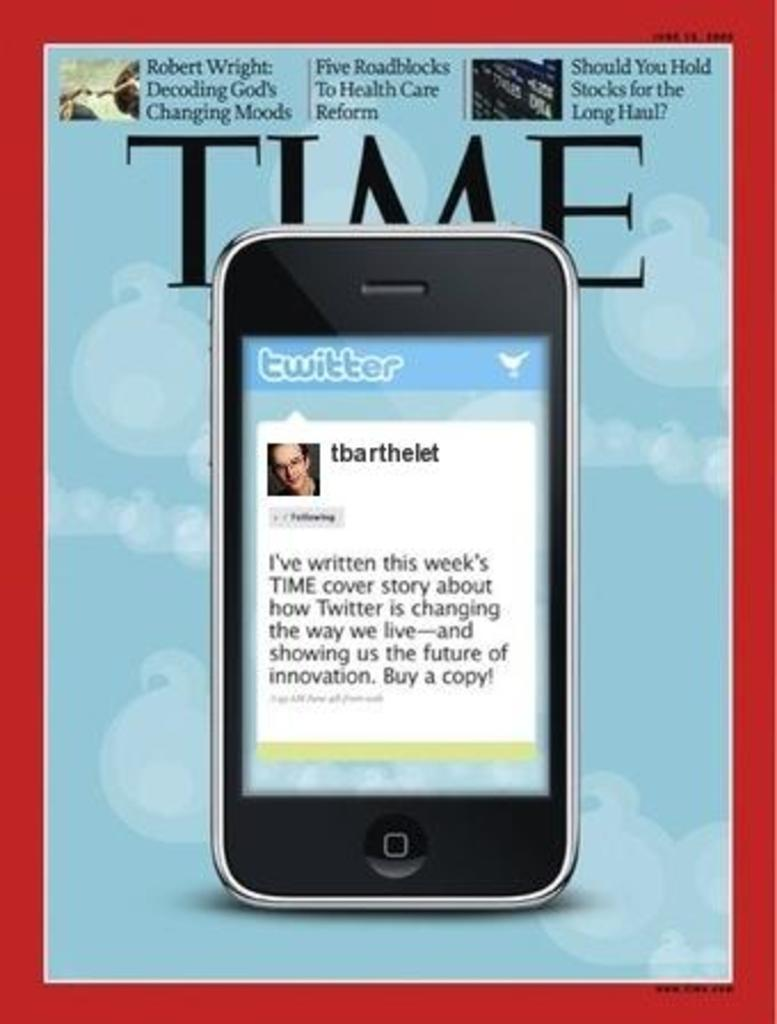Provide a one-sentence caption for the provided image. A Time magazine cover story about Twitter taking over the world. 